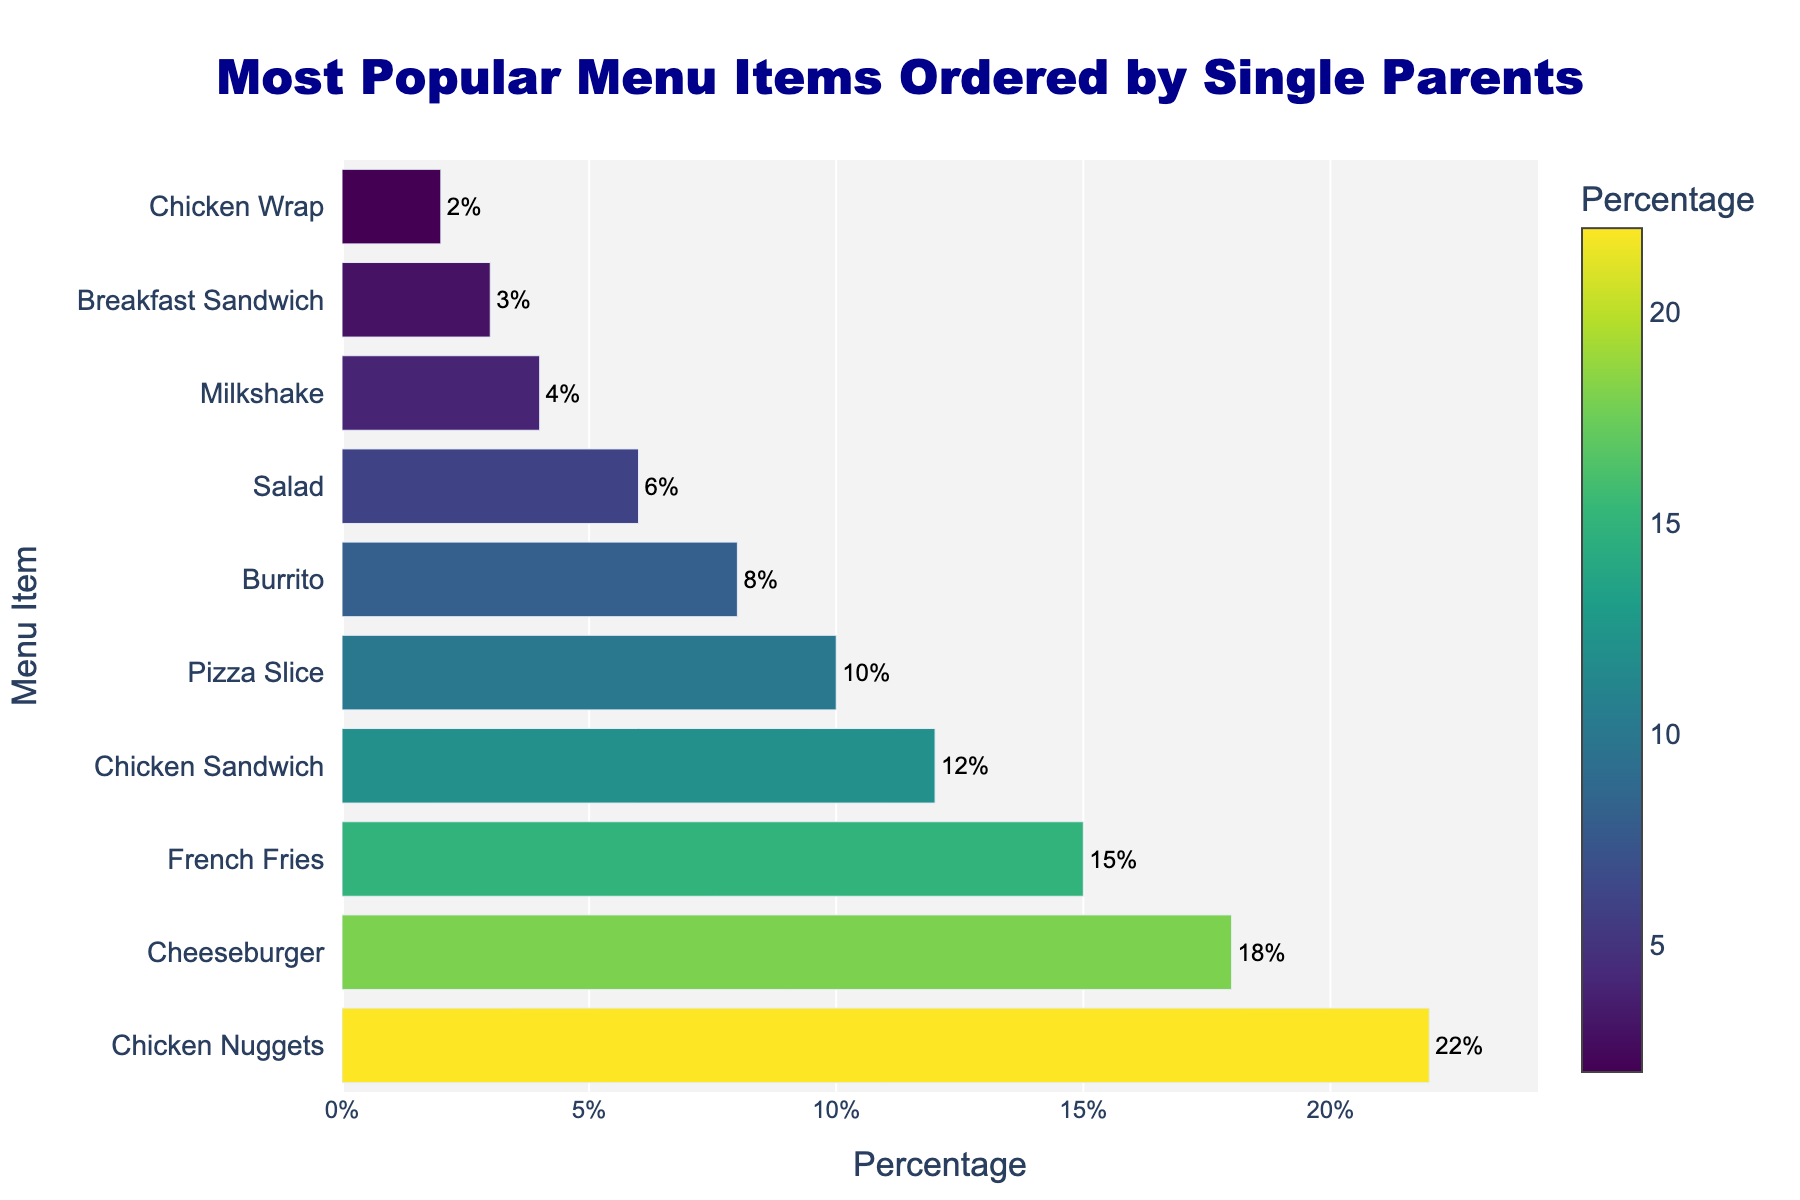What's the most popular menu item ordered by single parents? The bar representing Chicken Nuggets is the longest and has the highest percentage value. Therefore, Chicken Nuggets are the most popular menu item.
Answer: Chicken Nuggets What's the least popular menu item ordered by single parents? The bar representing Chicken Wrap is the shortest and has the lowest percentage value. Therefore, Chicken Wrap is the least popular menu item.
Answer: Chicken Wrap Which item is more popular, Burrito or Pizza Slice? Comparing the lengths of the bars and their percentage values, the Burrito has a lower percentage than Pizza Slice.
Answer: Pizza Slice How much more popular are Chicken Nuggets compared to a Cheeseburger? Chicken Nuggets have a percentage of 22%, and Cheeseburgers have 18%. The difference is 22 - 18 = 4%.
Answer: 4% What is the total percentage of orders made up by Chicken Nuggets, Cheeseburgers, and French Fries? Add the percentages of Chicken Nuggets (22%), Cheeseburgers (18%), and French Fries (15%). The total is 22 + 18 + 15 = 55%.
Answer: 55% Are there more total orders for items like Chicken Sandwich and Burrito compared to Pizza Slice and Salad? Add the percentages of Chicken Sandwich (12%) and Burrito (8%), which equals 12 + 8 = 20%. Then add the percentages of Pizza Slice (10%) and Salad (6%) which equals 10 + 6 = 16%. The first group has a higher total percentage.
Answer: Yes Which menu item contributes exactly 10% to the total orders? The bar corresponding to Pizza Slice shows a value of 10%.
Answer: Pizza Slice What is the combined percentage of all items that have a percentage lower than the Chicken Sandwich? Items lower than Chicken Sandwich are: Pizza Slice (10%), Burrito (8%), Salad (6%), Milkshake (4%), Breakfast Sandwich (3%), Chicken Wrap (2%). The total is 10 + 8 + 6 + 4 + 3 + 2 = 33%.
Answer: 33% How much more popular is French Fries compared to Milkshake? French Fries have 15%, and Milkshake has 4%. The difference is 15 - 4 = 11%.
Answer: 11% If you exclude the top 3 items, what is the average percentage of the remaining menu items? Excluding the top 3 items (Chicken Nuggets, Cheeseburger, French Fries) leaves: Chicken Sandwich (12%), Pizza Slice (10%), Burrito (8%), Salad (6%), Milkshake (4%), Breakfast Sandwich (3%), Chicken Wrap (2%). Their sum is 12 + 10 + 8 + 6 + 4 + 3 + 2 = 45%. There are 7 items, so the average is 45/7 = ~6.43%.
Answer: ~6.43% 